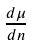<formula> <loc_0><loc_0><loc_500><loc_500>\frac { d \mu } { d n }</formula> 